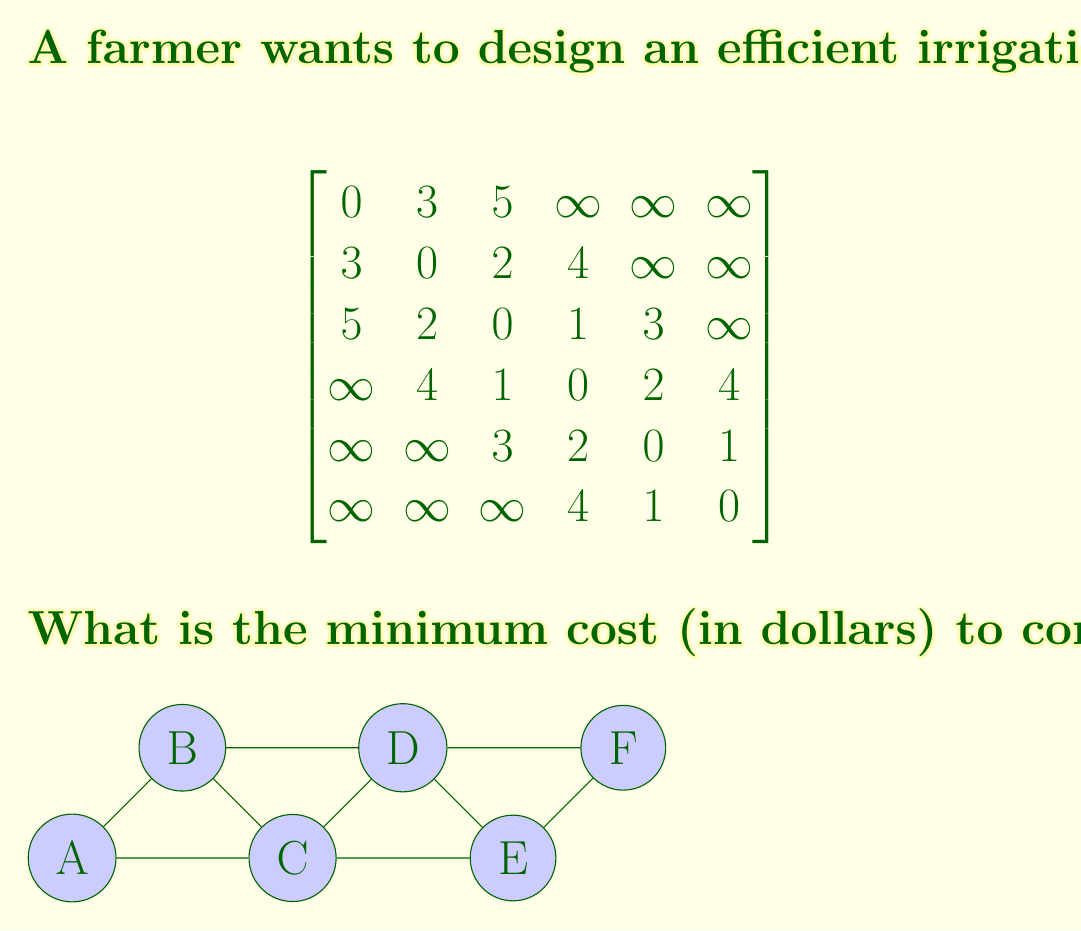Can you solve this math problem? To find the minimum cost of connecting all nodes in the irrigation system, we need to find the Minimum Spanning Tree (MST) of the given graph. We can use Kruskal's algorithm to solve this problem efficiently.

Steps to solve using Kruskal's algorithm:

1. Sort all edges in non-decreasing order of their weight (cost):
   (E,F): 1, (C,D): 1, (B,C): 2, (D,E): 2, (A,B): 3, (C,E): 3, (B,D): 4

2. Initialize an empty set to store the MST edges.

3. Iterate through the sorted edges:
   a. (E,F): 1 - Add to MST
   b. (C,D): 1 - Add to MST
   c. (B,C): 2 - Add to MST
   d. (D,E): 2 - Add to MST
   e. (A,B): 3 - Add to MST

4. Stop when we have added 5 edges (n-1, where n is the number of nodes).

The MST consists of the following edges: (E,F), (C,D), (B,C), (D,E), and (A,B).

To calculate the total cost:
$$ \text{Total Cost} = 1 + 1 + 2 + 2 + 3 = 9 $$

Since the costs in the adjacency matrix were given in hundreds of dollars, we multiply the result by 100 to get the final cost in dollars.

$$ \text{Final Cost} = 9 \times 100 = 900 \text{ dollars} $$
Answer: The minimum cost to connect all nodes in the irrigation system is $900. 